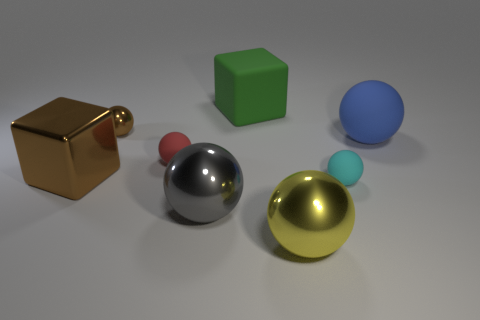There is a large metallic sphere that is on the right side of the block that is behind the small matte thing that is on the left side of the matte block; what is its color? yellow 